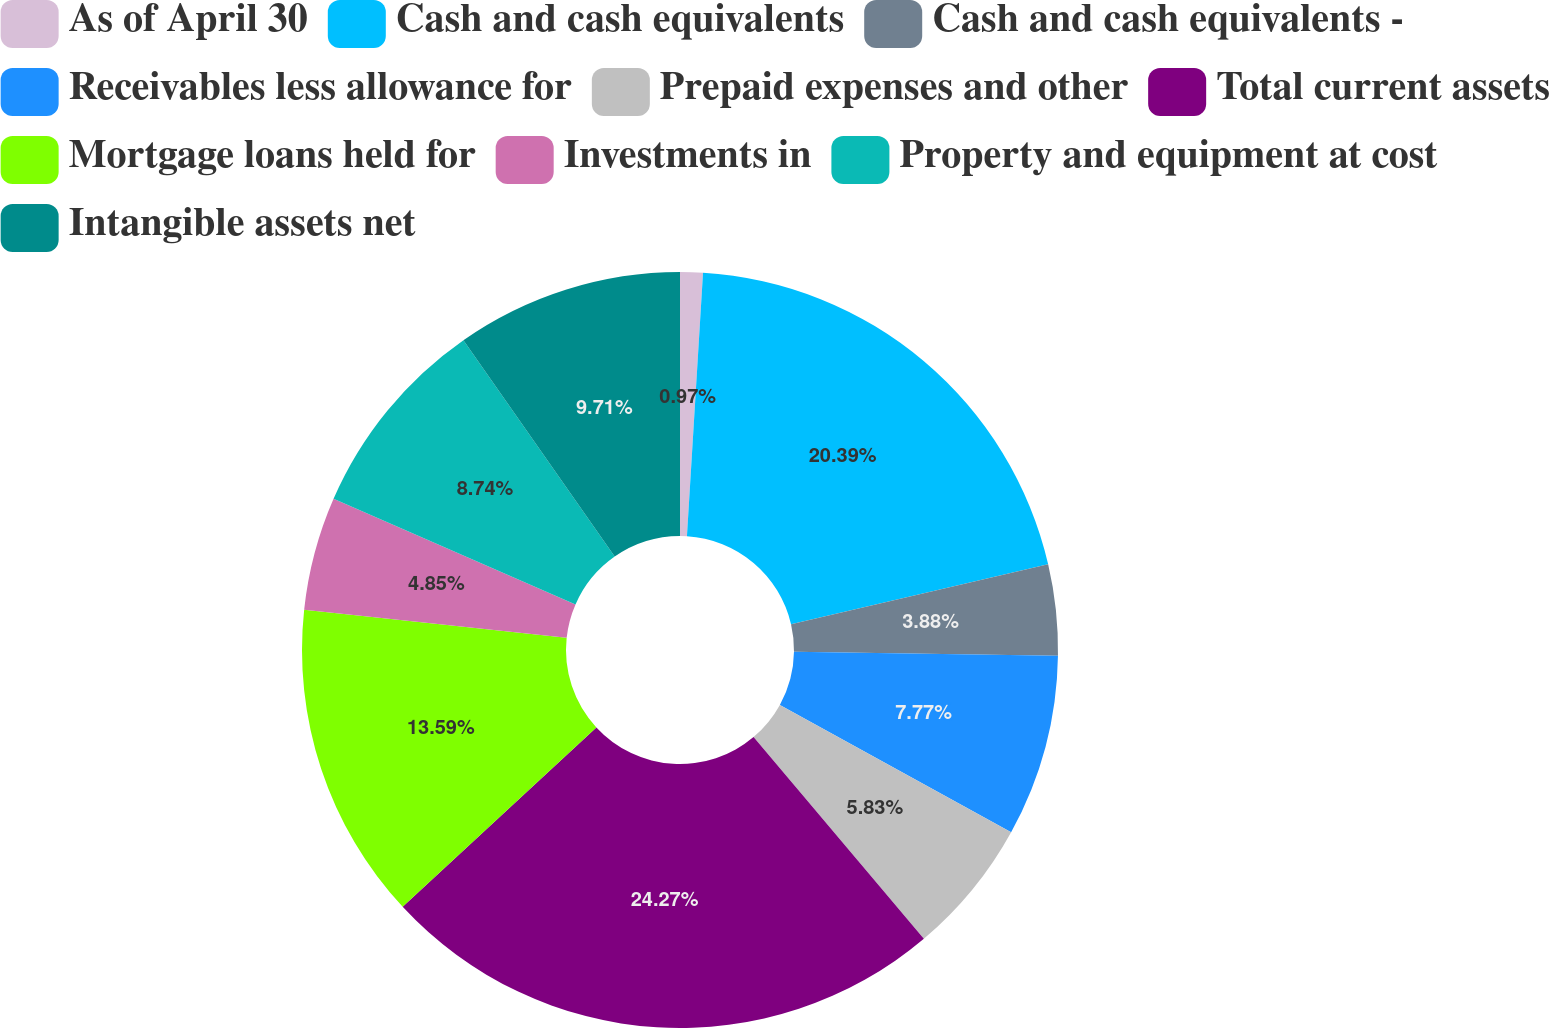<chart> <loc_0><loc_0><loc_500><loc_500><pie_chart><fcel>As of April 30<fcel>Cash and cash equivalents<fcel>Cash and cash equivalents -<fcel>Receivables less allowance for<fcel>Prepaid expenses and other<fcel>Total current assets<fcel>Mortgage loans held for<fcel>Investments in<fcel>Property and equipment at cost<fcel>Intangible assets net<nl><fcel>0.97%<fcel>20.39%<fcel>3.88%<fcel>7.77%<fcel>5.83%<fcel>24.27%<fcel>13.59%<fcel>4.85%<fcel>8.74%<fcel>9.71%<nl></chart> 